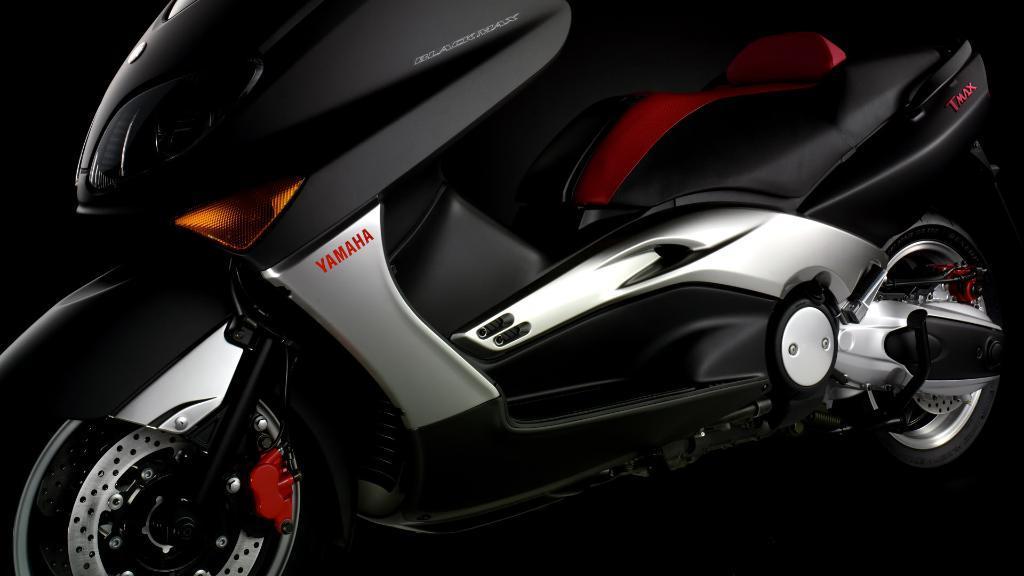Describe this image in one or two sentences. In this image we can see a motor vehicle which is placed on the surface. 